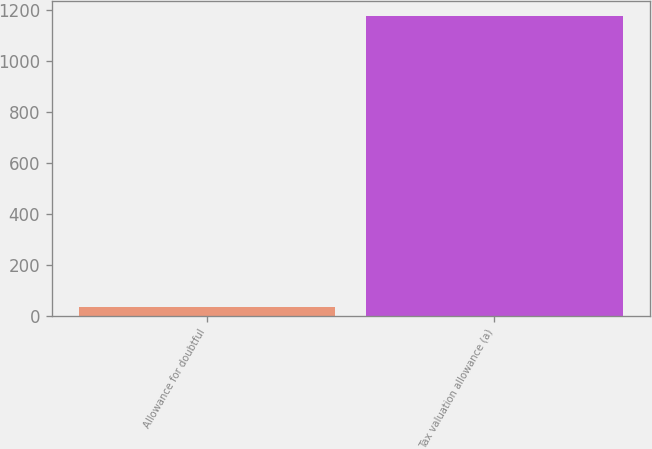<chart> <loc_0><loc_0><loc_500><loc_500><bar_chart><fcel>Allowance for doubtful<fcel>Tax valuation allowance (a)<nl><fcel>33<fcel>1178<nl></chart> 